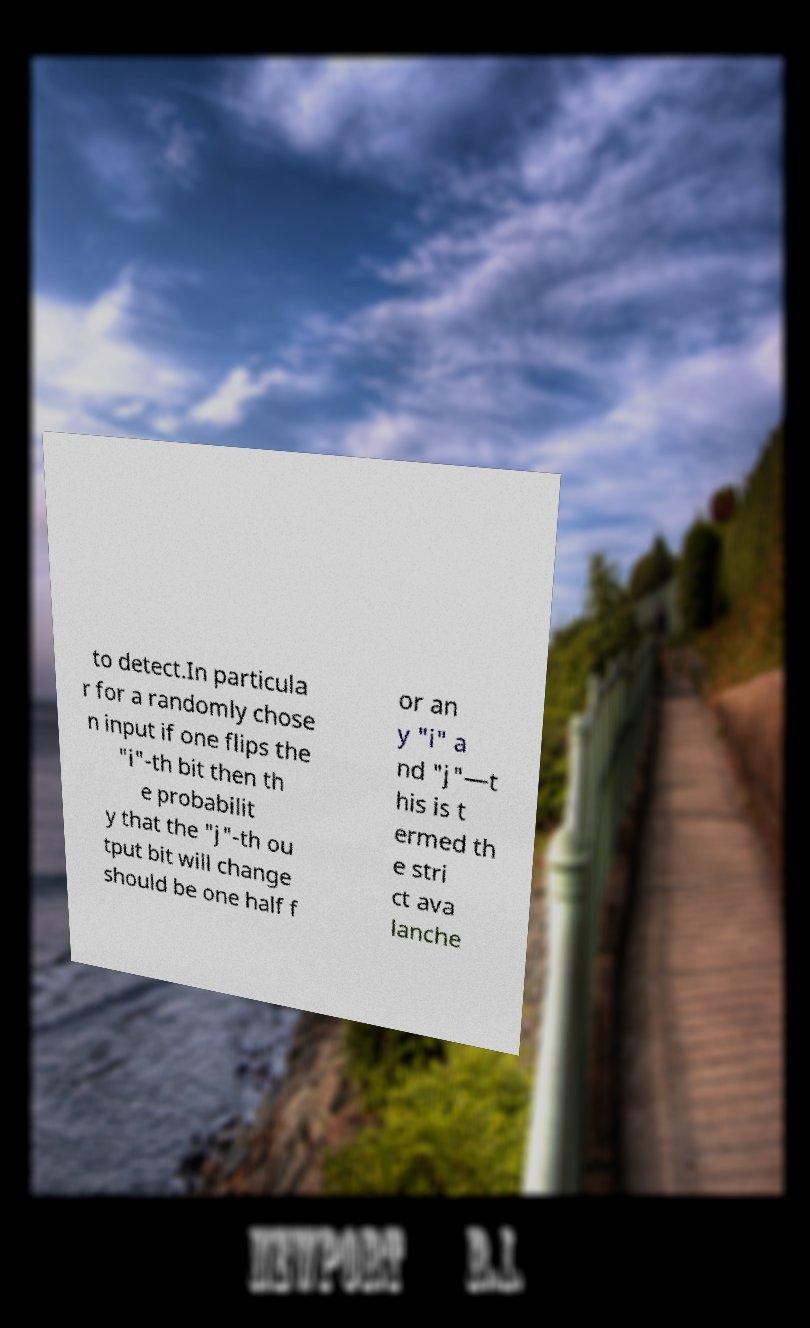Could you extract and type out the text from this image? to detect.In particula r for a randomly chose n input if one flips the "i"-th bit then th e probabilit y that the "j"-th ou tput bit will change should be one half f or an y "i" a nd "j"—t his is t ermed th e stri ct ava lanche 